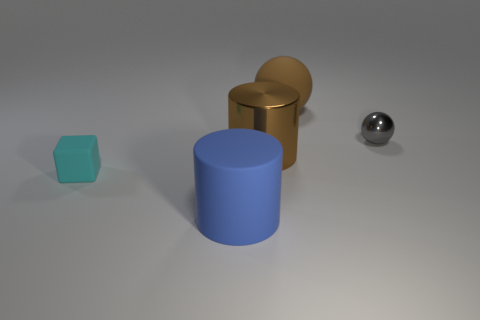Add 3 yellow shiny spheres. How many objects exist? 8 Subtract all blocks. How many objects are left? 4 Subtract all blue cylinders. How many cylinders are left? 1 Add 4 small cyan things. How many small cyan things exist? 5 Subtract 1 brown spheres. How many objects are left? 4 Subtract 1 cubes. How many cubes are left? 0 Subtract all brown cylinders. Subtract all blue balls. How many cylinders are left? 1 Subtract all blue spheres. How many blue cylinders are left? 1 Subtract all small gray spheres. Subtract all metal spheres. How many objects are left? 3 Add 1 small gray spheres. How many small gray spheres are left? 2 